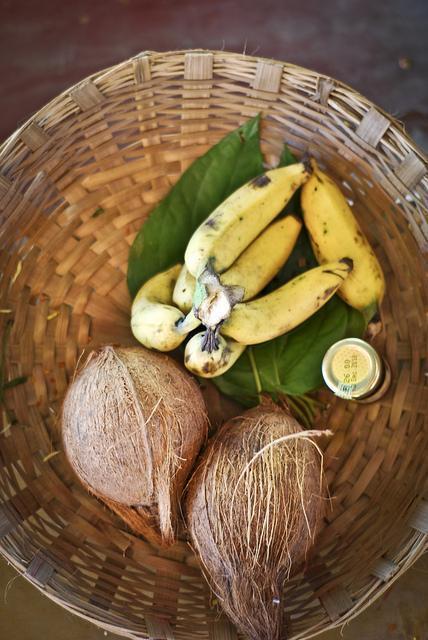What is the best climate for these fruits to grow in?
Answer the question by selecting the correct answer among the 4 following choices.
Options: Dry, arid, polar, tropical. Tropical. 